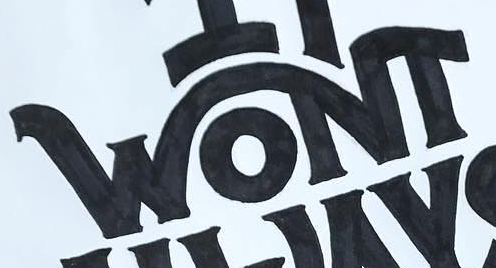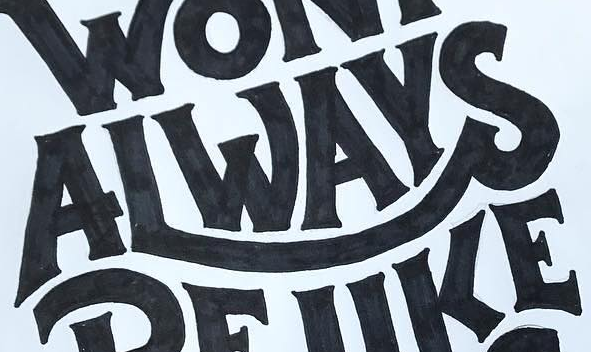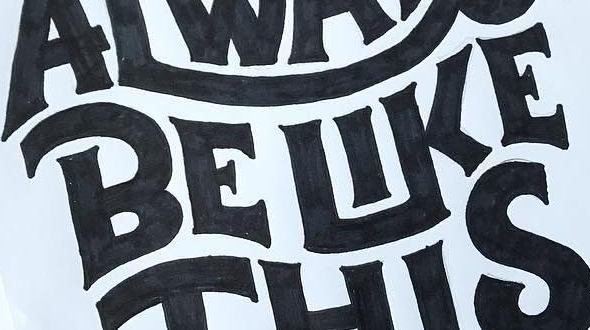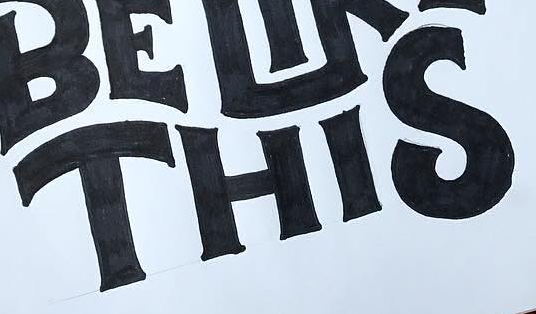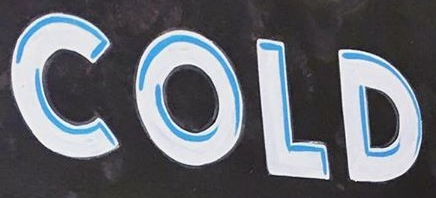What words can you see in these images in sequence, separated by a semicolon? WONT; ALWAYS; BELIKE; THIS; COLD 